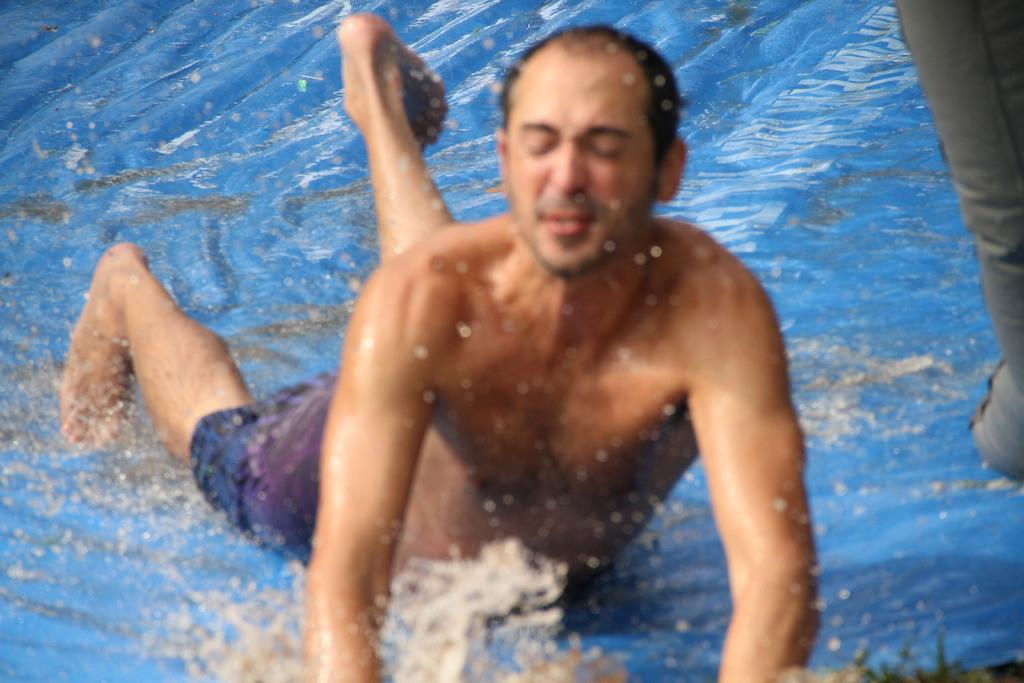Who is in the image? There is a man in the image. What is the man doing in the image? The man is lying on a slide. What is the man wearing in the image? The man is wearing purple shorts. What is the condition of the slide in the image? Water is present on the slide. What type of music can be heard playing in the background of the image? There is no music present in the image, as it is a still photograph. 